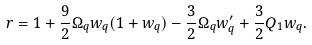<formula> <loc_0><loc_0><loc_500><loc_500>r = 1 + \frac { 9 } { 2 } \Omega _ { q } w _ { q } ( 1 + w _ { q } ) - \frac { 3 } { 2 } \Omega _ { q } w _ { q } ^ { \prime } + \frac { 3 } { 2 } Q _ { 1 } w _ { q } .</formula> 